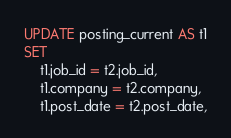<code> <loc_0><loc_0><loc_500><loc_500><_SQL_>UPDATE posting_current AS t1
SET
    t1.job_id = t2.job_id,
    t1.company = t2.company,
    t1.post_date = t2.post_date,</code> 